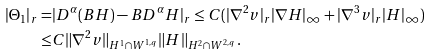<formula> <loc_0><loc_0><loc_500><loc_500>| \Theta _ { 1 } | _ { r } = & | D ^ { \alpha } ( B H ) - B D ^ { \alpha } H | _ { r } \leq C ( | \nabla ^ { 2 } v | _ { r } | \nabla H | _ { \infty } + | \nabla ^ { 3 } v | _ { r } | H | _ { \infty } ) \\ \leq & C \| \nabla ^ { 2 } v \| _ { H ^ { 1 } \cap W ^ { 1 , q } } \| H \| _ { H ^ { 2 } \cap W ^ { 2 , q } } .</formula> 